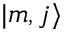Convert formula to latex. <formula><loc_0><loc_0><loc_500><loc_500>| m , j \rangle</formula> 